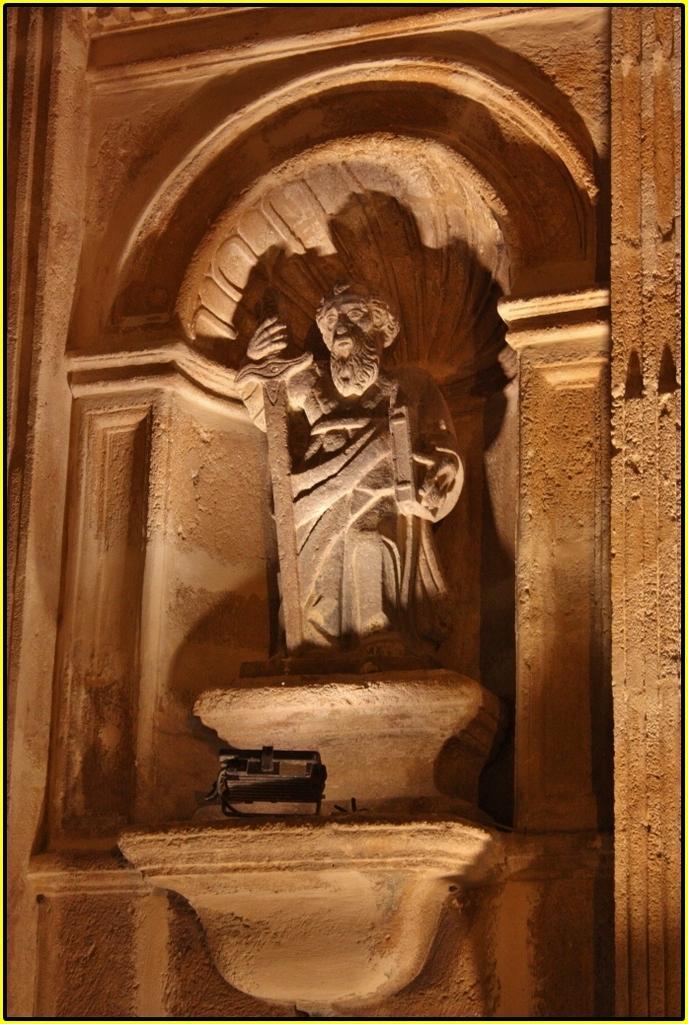Describe this image in one or two sentences. In this picture we can see the statue of a person holding a sword in his hand. There is a black object and a few things are visible on the wall. 